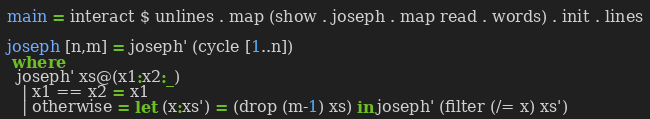Convert code to text. <code><loc_0><loc_0><loc_500><loc_500><_Haskell_>main = interact $ unlines . map (show . joseph . map read . words) . init . lines

joseph [n,m] = joseph' (cycle [1..n])
 where
  joseph' xs@(x1:x2:_)
   | x1 == x2 = x1
   | otherwise = let (x:xs') = (drop (m-1) xs) in joseph' (filter (/= x) xs')</code> 